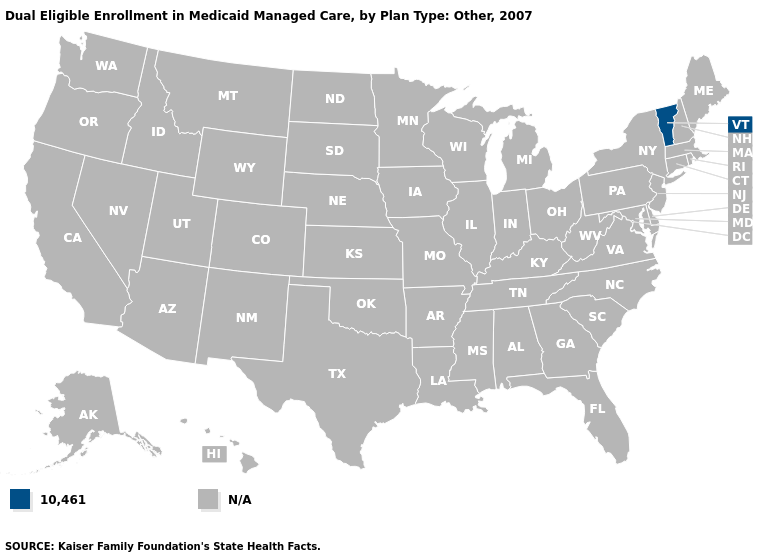Is the legend a continuous bar?
Short answer required. No. What is the lowest value in the Northeast?
Quick response, please. 10,461. Name the states that have a value in the range N/A?
Quick response, please. Alabama, Alaska, Arizona, Arkansas, California, Colorado, Connecticut, Delaware, Florida, Georgia, Hawaii, Idaho, Illinois, Indiana, Iowa, Kansas, Kentucky, Louisiana, Maine, Maryland, Massachusetts, Michigan, Minnesota, Mississippi, Missouri, Montana, Nebraska, Nevada, New Hampshire, New Jersey, New Mexico, New York, North Carolina, North Dakota, Ohio, Oklahoma, Oregon, Pennsylvania, Rhode Island, South Carolina, South Dakota, Tennessee, Texas, Utah, Virginia, Washington, West Virginia, Wisconsin, Wyoming. What is the value of Illinois?
Be succinct. N/A. What is the lowest value in the Northeast?
Write a very short answer. 10,461. What is the lowest value in the USA?
Quick response, please. 10,461. 